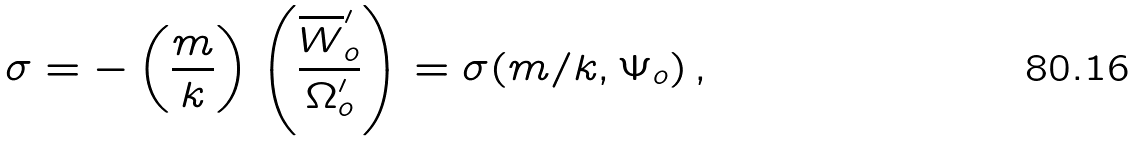Convert formula to latex. <formula><loc_0><loc_0><loc_500><loc_500>\sigma = - \left ( \frac { m } { k } \right ) \left ( \frac { \overline { W } ^ { \prime } _ { o } } { \Omega ^ { \prime } _ { o } } \right ) = \sigma ( m / k , \Psi _ { o } ) \, ,</formula> 